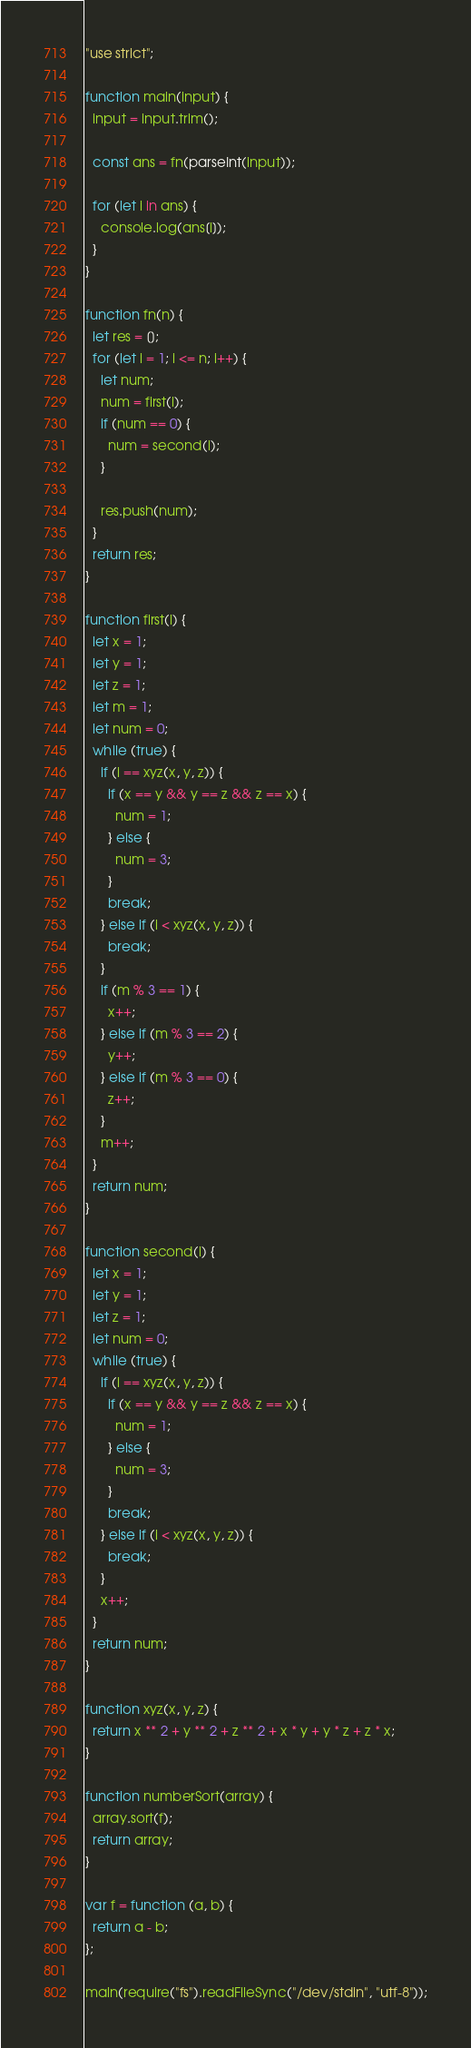Convert code to text. <code><loc_0><loc_0><loc_500><loc_500><_JavaScript_>"use strict";

function main(input) {
  input = input.trim();

  const ans = fn(parseInt(input));

  for (let i in ans) {
    console.log(ans[i]);
  }
}

function fn(n) {
  let res = [];
  for (let i = 1; i <= n; i++) {
    let num;
    num = first(i);
    if (num == 0) {
      num = second(i);
    }

    res.push(num);
  }
  return res;
}

function first(i) {
  let x = 1;
  let y = 1;
  let z = 1;
  let m = 1;
  let num = 0;
  while (true) {
    if (i == xyz(x, y, z)) {
      if (x == y && y == z && z == x) {
        num = 1;
      } else {
        num = 3;
      }
      break;
    } else if (i < xyz(x, y, z)) {
      break;
    }
    if (m % 3 == 1) {
      x++;
    } else if (m % 3 == 2) {
      y++;
    } else if (m % 3 == 0) {
      z++;
    }
    m++;
  }
  return num;
}

function second(i) {
  let x = 1;
  let y = 1;
  let z = 1;
  let num = 0;
  while (true) {
    if (i == xyz(x, y, z)) {
      if (x == y && y == z && z == x) {
        num = 1;
      } else {
        num = 3;
      }
      break;
    } else if (i < xyz(x, y, z)) {
      break;
    }
    x++;
  }
  return num;
}

function xyz(x, y, z) {
  return x ** 2 + y ** 2 + z ** 2 + x * y + y * z + z * x;
}

function numberSort(array) {
  array.sort(f);
  return array;
}

var f = function (a, b) {
  return a - b;
};

main(require("fs").readFileSync("/dev/stdin", "utf-8"));
</code> 